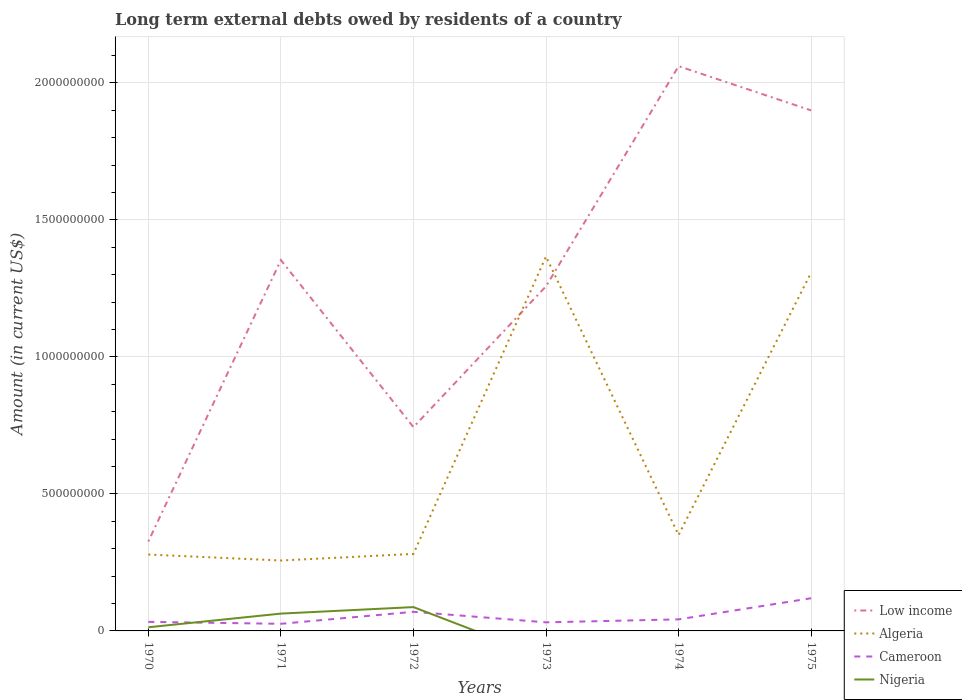How many different coloured lines are there?
Your answer should be compact. 4. Is the number of lines equal to the number of legend labels?
Keep it short and to the point. No. Across all years, what is the maximum amount of long-term external debts owed by residents in Cameroon?
Keep it short and to the point. 2.60e+07. What is the total amount of long-term external debts owed by residents in Low income in the graph?
Provide a succinct answer. -6.42e+08. What is the difference between the highest and the second highest amount of long-term external debts owed by residents in Nigeria?
Offer a very short reply. 8.69e+07. What is the difference between the highest and the lowest amount of long-term external debts owed by residents in Algeria?
Offer a terse response. 2. Is the amount of long-term external debts owed by residents in Low income strictly greater than the amount of long-term external debts owed by residents in Cameroon over the years?
Keep it short and to the point. No. How many years are there in the graph?
Ensure brevity in your answer.  6. What is the difference between two consecutive major ticks on the Y-axis?
Provide a succinct answer. 5.00e+08. Where does the legend appear in the graph?
Your answer should be very brief. Bottom right. How many legend labels are there?
Offer a very short reply. 4. What is the title of the graph?
Keep it short and to the point. Long term external debts owed by residents of a country. What is the label or title of the Y-axis?
Ensure brevity in your answer.  Amount (in current US$). What is the Amount (in current US$) in Low income in 1970?
Ensure brevity in your answer.  3.26e+08. What is the Amount (in current US$) of Algeria in 1970?
Give a very brief answer. 2.79e+08. What is the Amount (in current US$) in Cameroon in 1970?
Make the answer very short. 3.30e+07. What is the Amount (in current US$) of Nigeria in 1970?
Provide a short and direct response. 1.33e+07. What is the Amount (in current US$) in Low income in 1971?
Your answer should be very brief. 1.35e+09. What is the Amount (in current US$) in Algeria in 1971?
Your answer should be compact. 2.57e+08. What is the Amount (in current US$) in Cameroon in 1971?
Your answer should be compact. 2.60e+07. What is the Amount (in current US$) in Nigeria in 1971?
Your answer should be very brief. 6.32e+07. What is the Amount (in current US$) in Low income in 1972?
Make the answer very short. 7.44e+08. What is the Amount (in current US$) of Algeria in 1972?
Keep it short and to the point. 2.81e+08. What is the Amount (in current US$) of Cameroon in 1972?
Give a very brief answer. 6.98e+07. What is the Amount (in current US$) of Nigeria in 1972?
Your response must be concise. 8.69e+07. What is the Amount (in current US$) of Low income in 1973?
Ensure brevity in your answer.  1.26e+09. What is the Amount (in current US$) of Algeria in 1973?
Give a very brief answer. 1.37e+09. What is the Amount (in current US$) in Cameroon in 1973?
Your answer should be compact. 3.13e+07. What is the Amount (in current US$) in Nigeria in 1973?
Offer a very short reply. 0. What is the Amount (in current US$) in Low income in 1974?
Keep it short and to the point. 2.06e+09. What is the Amount (in current US$) in Algeria in 1974?
Offer a terse response. 3.50e+08. What is the Amount (in current US$) of Cameroon in 1974?
Your response must be concise. 4.22e+07. What is the Amount (in current US$) in Nigeria in 1974?
Provide a succinct answer. 0. What is the Amount (in current US$) of Low income in 1975?
Provide a short and direct response. 1.90e+09. What is the Amount (in current US$) of Algeria in 1975?
Your response must be concise. 1.31e+09. What is the Amount (in current US$) of Cameroon in 1975?
Provide a short and direct response. 1.19e+08. Across all years, what is the maximum Amount (in current US$) of Low income?
Your answer should be very brief. 2.06e+09. Across all years, what is the maximum Amount (in current US$) of Algeria?
Provide a short and direct response. 1.37e+09. Across all years, what is the maximum Amount (in current US$) in Cameroon?
Keep it short and to the point. 1.19e+08. Across all years, what is the maximum Amount (in current US$) of Nigeria?
Keep it short and to the point. 8.69e+07. Across all years, what is the minimum Amount (in current US$) in Low income?
Your response must be concise. 3.26e+08. Across all years, what is the minimum Amount (in current US$) in Algeria?
Offer a terse response. 2.57e+08. Across all years, what is the minimum Amount (in current US$) in Cameroon?
Offer a terse response. 2.60e+07. Across all years, what is the minimum Amount (in current US$) of Nigeria?
Keep it short and to the point. 0. What is the total Amount (in current US$) of Low income in the graph?
Provide a succinct answer. 7.64e+09. What is the total Amount (in current US$) in Algeria in the graph?
Provide a succinct answer. 3.84e+09. What is the total Amount (in current US$) in Cameroon in the graph?
Provide a succinct answer. 3.22e+08. What is the total Amount (in current US$) of Nigeria in the graph?
Your answer should be very brief. 1.63e+08. What is the difference between the Amount (in current US$) of Low income in 1970 and that in 1971?
Provide a short and direct response. -1.03e+09. What is the difference between the Amount (in current US$) in Algeria in 1970 and that in 1971?
Your response must be concise. 2.18e+07. What is the difference between the Amount (in current US$) of Cameroon in 1970 and that in 1971?
Provide a short and direct response. 7.06e+06. What is the difference between the Amount (in current US$) of Nigeria in 1970 and that in 1971?
Your answer should be compact. -4.99e+07. What is the difference between the Amount (in current US$) of Low income in 1970 and that in 1972?
Keep it short and to the point. -4.17e+08. What is the difference between the Amount (in current US$) of Algeria in 1970 and that in 1972?
Keep it short and to the point. -2.27e+06. What is the difference between the Amount (in current US$) of Cameroon in 1970 and that in 1972?
Keep it short and to the point. -3.68e+07. What is the difference between the Amount (in current US$) of Nigeria in 1970 and that in 1972?
Offer a terse response. -7.36e+07. What is the difference between the Amount (in current US$) of Low income in 1970 and that in 1973?
Offer a very short reply. -9.31e+08. What is the difference between the Amount (in current US$) of Algeria in 1970 and that in 1973?
Your answer should be very brief. -1.09e+09. What is the difference between the Amount (in current US$) of Cameroon in 1970 and that in 1973?
Offer a terse response. 1.72e+06. What is the difference between the Amount (in current US$) of Low income in 1970 and that in 1974?
Your response must be concise. -1.73e+09. What is the difference between the Amount (in current US$) in Algeria in 1970 and that in 1974?
Keep it short and to the point. -7.12e+07. What is the difference between the Amount (in current US$) of Cameroon in 1970 and that in 1974?
Your answer should be very brief. -9.16e+06. What is the difference between the Amount (in current US$) in Low income in 1970 and that in 1975?
Keep it short and to the point. -1.57e+09. What is the difference between the Amount (in current US$) in Algeria in 1970 and that in 1975?
Keep it short and to the point. -1.03e+09. What is the difference between the Amount (in current US$) in Cameroon in 1970 and that in 1975?
Your answer should be compact. -8.63e+07. What is the difference between the Amount (in current US$) in Low income in 1971 and that in 1972?
Your answer should be compact. 6.10e+08. What is the difference between the Amount (in current US$) of Algeria in 1971 and that in 1972?
Your answer should be very brief. -2.41e+07. What is the difference between the Amount (in current US$) of Cameroon in 1971 and that in 1972?
Make the answer very short. -4.38e+07. What is the difference between the Amount (in current US$) of Nigeria in 1971 and that in 1972?
Your response must be concise. -2.37e+07. What is the difference between the Amount (in current US$) in Low income in 1971 and that in 1973?
Ensure brevity in your answer.  9.57e+07. What is the difference between the Amount (in current US$) of Algeria in 1971 and that in 1973?
Your answer should be compact. -1.11e+09. What is the difference between the Amount (in current US$) of Cameroon in 1971 and that in 1973?
Offer a very short reply. -5.34e+06. What is the difference between the Amount (in current US$) in Low income in 1971 and that in 1974?
Offer a very short reply. -7.08e+08. What is the difference between the Amount (in current US$) in Algeria in 1971 and that in 1974?
Ensure brevity in your answer.  -9.29e+07. What is the difference between the Amount (in current US$) of Cameroon in 1971 and that in 1974?
Provide a short and direct response. -1.62e+07. What is the difference between the Amount (in current US$) of Low income in 1971 and that in 1975?
Provide a short and direct response. -5.46e+08. What is the difference between the Amount (in current US$) of Algeria in 1971 and that in 1975?
Your response must be concise. -1.05e+09. What is the difference between the Amount (in current US$) in Cameroon in 1971 and that in 1975?
Make the answer very short. -9.33e+07. What is the difference between the Amount (in current US$) of Low income in 1972 and that in 1973?
Keep it short and to the point. -5.14e+08. What is the difference between the Amount (in current US$) of Algeria in 1972 and that in 1973?
Keep it short and to the point. -1.09e+09. What is the difference between the Amount (in current US$) of Cameroon in 1972 and that in 1973?
Offer a very short reply. 3.85e+07. What is the difference between the Amount (in current US$) of Low income in 1972 and that in 1974?
Give a very brief answer. -1.32e+09. What is the difference between the Amount (in current US$) of Algeria in 1972 and that in 1974?
Provide a succinct answer. -6.89e+07. What is the difference between the Amount (in current US$) in Cameroon in 1972 and that in 1974?
Your answer should be very brief. 2.76e+07. What is the difference between the Amount (in current US$) in Low income in 1972 and that in 1975?
Give a very brief answer. -1.16e+09. What is the difference between the Amount (in current US$) of Algeria in 1972 and that in 1975?
Ensure brevity in your answer.  -1.03e+09. What is the difference between the Amount (in current US$) in Cameroon in 1972 and that in 1975?
Ensure brevity in your answer.  -4.95e+07. What is the difference between the Amount (in current US$) of Low income in 1973 and that in 1974?
Make the answer very short. -8.03e+08. What is the difference between the Amount (in current US$) of Algeria in 1973 and that in 1974?
Your answer should be very brief. 1.02e+09. What is the difference between the Amount (in current US$) in Cameroon in 1973 and that in 1974?
Make the answer very short. -1.09e+07. What is the difference between the Amount (in current US$) in Low income in 1973 and that in 1975?
Offer a very short reply. -6.42e+08. What is the difference between the Amount (in current US$) of Algeria in 1973 and that in 1975?
Make the answer very short. 5.86e+07. What is the difference between the Amount (in current US$) in Cameroon in 1973 and that in 1975?
Offer a very short reply. -8.80e+07. What is the difference between the Amount (in current US$) of Low income in 1974 and that in 1975?
Your answer should be very brief. 1.61e+08. What is the difference between the Amount (in current US$) in Algeria in 1974 and that in 1975?
Your answer should be very brief. -9.58e+08. What is the difference between the Amount (in current US$) of Cameroon in 1974 and that in 1975?
Your response must be concise. -7.71e+07. What is the difference between the Amount (in current US$) in Low income in 1970 and the Amount (in current US$) in Algeria in 1971?
Keep it short and to the point. 6.93e+07. What is the difference between the Amount (in current US$) in Low income in 1970 and the Amount (in current US$) in Cameroon in 1971?
Give a very brief answer. 3.00e+08. What is the difference between the Amount (in current US$) in Low income in 1970 and the Amount (in current US$) in Nigeria in 1971?
Make the answer very short. 2.63e+08. What is the difference between the Amount (in current US$) in Algeria in 1970 and the Amount (in current US$) in Cameroon in 1971?
Your response must be concise. 2.53e+08. What is the difference between the Amount (in current US$) of Algeria in 1970 and the Amount (in current US$) of Nigeria in 1971?
Your response must be concise. 2.16e+08. What is the difference between the Amount (in current US$) of Cameroon in 1970 and the Amount (in current US$) of Nigeria in 1971?
Keep it short and to the point. -3.02e+07. What is the difference between the Amount (in current US$) in Low income in 1970 and the Amount (in current US$) in Algeria in 1972?
Keep it short and to the point. 4.52e+07. What is the difference between the Amount (in current US$) of Low income in 1970 and the Amount (in current US$) of Cameroon in 1972?
Offer a very short reply. 2.56e+08. What is the difference between the Amount (in current US$) in Low income in 1970 and the Amount (in current US$) in Nigeria in 1972?
Provide a short and direct response. 2.39e+08. What is the difference between the Amount (in current US$) in Algeria in 1970 and the Amount (in current US$) in Cameroon in 1972?
Make the answer very short. 2.09e+08. What is the difference between the Amount (in current US$) of Algeria in 1970 and the Amount (in current US$) of Nigeria in 1972?
Your response must be concise. 1.92e+08. What is the difference between the Amount (in current US$) in Cameroon in 1970 and the Amount (in current US$) in Nigeria in 1972?
Make the answer very short. -5.39e+07. What is the difference between the Amount (in current US$) in Low income in 1970 and the Amount (in current US$) in Algeria in 1973?
Offer a very short reply. -1.04e+09. What is the difference between the Amount (in current US$) of Low income in 1970 and the Amount (in current US$) of Cameroon in 1973?
Your response must be concise. 2.95e+08. What is the difference between the Amount (in current US$) in Algeria in 1970 and the Amount (in current US$) in Cameroon in 1973?
Give a very brief answer. 2.47e+08. What is the difference between the Amount (in current US$) of Low income in 1970 and the Amount (in current US$) of Algeria in 1974?
Your answer should be compact. -2.36e+07. What is the difference between the Amount (in current US$) of Low income in 1970 and the Amount (in current US$) of Cameroon in 1974?
Keep it short and to the point. 2.84e+08. What is the difference between the Amount (in current US$) of Algeria in 1970 and the Amount (in current US$) of Cameroon in 1974?
Provide a succinct answer. 2.37e+08. What is the difference between the Amount (in current US$) in Low income in 1970 and the Amount (in current US$) in Algeria in 1975?
Provide a short and direct response. -9.81e+08. What is the difference between the Amount (in current US$) in Low income in 1970 and the Amount (in current US$) in Cameroon in 1975?
Offer a terse response. 2.07e+08. What is the difference between the Amount (in current US$) of Algeria in 1970 and the Amount (in current US$) of Cameroon in 1975?
Keep it short and to the point. 1.59e+08. What is the difference between the Amount (in current US$) of Low income in 1971 and the Amount (in current US$) of Algeria in 1972?
Your answer should be compact. 1.07e+09. What is the difference between the Amount (in current US$) in Low income in 1971 and the Amount (in current US$) in Cameroon in 1972?
Provide a short and direct response. 1.28e+09. What is the difference between the Amount (in current US$) of Low income in 1971 and the Amount (in current US$) of Nigeria in 1972?
Offer a very short reply. 1.27e+09. What is the difference between the Amount (in current US$) of Algeria in 1971 and the Amount (in current US$) of Cameroon in 1972?
Give a very brief answer. 1.87e+08. What is the difference between the Amount (in current US$) in Algeria in 1971 and the Amount (in current US$) in Nigeria in 1972?
Your answer should be compact. 1.70e+08. What is the difference between the Amount (in current US$) in Cameroon in 1971 and the Amount (in current US$) in Nigeria in 1972?
Provide a succinct answer. -6.10e+07. What is the difference between the Amount (in current US$) of Low income in 1971 and the Amount (in current US$) of Algeria in 1973?
Ensure brevity in your answer.  -1.29e+07. What is the difference between the Amount (in current US$) in Low income in 1971 and the Amount (in current US$) in Cameroon in 1973?
Ensure brevity in your answer.  1.32e+09. What is the difference between the Amount (in current US$) in Algeria in 1971 and the Amount (in current US$) in Cameroon in 1973?
Make the answer very short. 2.26e+08. What is the difference between the Amount (in current US$) of Low income in 1971 and the Amount (in current US$) of Algeria in 1974?
Offer a terse response. 1.00e+09. What is the difference between the Amount (in current US$) of Low income in 1971 and the Amount (in current US$) of Cameroon in 1974?
Your answer should be compact. 1.31e+09. What is the difference between the Amount (in current US$) of Algeria in 1971 and the Amount (in current US$) of Cameroon in 1974?
Your response must be concise. 2.15e+08. What is the difference between the Amount (in current US$) in Low income in 1971 and the Amount (in current US$) in Algeria in 1975?
Provide a succinct answer. 4.57e+07. What is the difference between the Amount (in current US$) of Low income in 1971 and the Amount (in current US$) of Cameroon in 1975?
Make the answer very short. 1.23e+09. What is the difference between the Amount (in current US$) in Algeria in 1971 and the Amount (in current US$) in Cameroon in 1975?
Ensure brevity in your answer.  1.38e+08. What is the difference between the Amount (in current US$) in Low income in 1972 and the Amount (in current US$) in Algeria in 1973?
Keep it short and to the point. -6.23e+08. What is the difference between the Amount (in current US$) in Low income in 1972 and the Amount (in current US$) in Cameroon in 1973?
Your response must be concise. 7.12e+08. What is the difference between the Amount (in current US$) of Algeria in 1972 and the Amount (in current US$) of Cameroon in 1973?
Give a very brief answer. 2.50e+08. What is the difference between the Amount (in current US$) of Low income in 1972 and the Amount (in current US$) of Algeria in 1974?
Provide a short and direct response. 3.94e+08. What is the difference between the Amount (in current US$) in Low income in 1972 and the Amount (in current US$) in Cameroon in 1974?
Your response must be concise. 7.02e+08. What is the difference between the Amount (in current US$) in Algeria in 1972 and the Amount (in current US$) in Cameroon in 1974?
Give a very brief answer. 2.39e+08. What is the difference between the Amount (in current US$) of Low income in 1972 and the Amount (in current US$) of Algeria in 1975?
Give a very brief answer. -5.64e+08. What is the difference between the Amount (in current US$) of Low income in 1972 and the Amount (in current US$) of Cameroon in 1975?
Make the answer very short. 6.24e+08. What is the difference between the Amount (in current US$) in Algeria in 1972 and the Amount (in current US$) in Cameroon in 1975?
Keep it short and to the point. 1.62e+08. What is the difference between the Amount (in current US$) in Low income in 1973 and the Amount (in current US$) in Algeria in 1974?
Your answer should be compact. 9.08e+08. What is the difference between the Amount (in current US$) in Low income in 1973 and the Amount (in current US$) in Cameroon in 1974?
Your answer should be very brief. 1.22e+09. What is the difference between the Amount (in current US$) of Algeria in 1973 and the Amount (in current US$) of Cameroon in 1974?
Offer a terse response. 1.32e+09. What is the difference between the Amount (in current US$) of Low income in 1973 and the Amount (in current US$) of Algeria in 1975?
Your answer should be compact. -5.00e+07. What is the difference between the Amount (in current US$) of Low income in 1973 and the Amount (in current US$) of Cameroon in 1975?
Your response must be concise. 1.14e+09. What is the difference between the Amount (in current US$) in Algeria in 1973 and the Amount (in current US$) in Cameroon in 1975?
Your response must be concise. 1.25e+09. What is the difference between the Amount (in current US$) in Low income in 1974 and the Amount (in current US$) in Algeria in 1975?
Offer a terse response. 7.53e+08. What is the difference between the Amount (in current US$) in Low income in 1974 and the Amount (in current US$) in Cameroon in 1975?
Ensure brevity in your answer.  1.94e+09. What is the difference between the Amount (in current US$) of Algeria in 1974 and the Amount (in current US$) of Cameroon in 1975?
Your response must be concise. 2.31e+08. What is the average Amount (in current US$) of Low income per year?
Your answer should be compact. 1.27e+09. What is the average Amount (in current US$) in Algeria per year?
Keep it short and to the point. 6.40e+08. What is the average Amount (in current US$) of Cameroon per year?
Make the answer very short. 5.36e+07. What is the average Amount (in current US$) in Nigeria per year?
Your response must be concise. 2.72e+07. In the year 1970, what is the difference between the Amount (in current US$) in Low income and Amount (in current US$) in Algeria?
Give a very brief answer. 4.75e+07. In the year 1970, what is the difference between the Amount (in current US$) in Low income and Amount (in current US$) in Cameroon?
Keep it short and to the point. 2.93e+08. In the year 1970, what is the difference between the Amount (in current US$) in Low income and Amount (in current US$) in Nigeria?
Your answer should be compact. 3.13e+08. In the year 1970, what is the difference between the Amount (in current US$) of Algeria and Amount (in current US$) of Cameroon?
Make the answer very short. 2.46e+08. In the year 1970, what is the difference between the Amount (in current US$) in Algeria and Amount (in current US$) in Nigeria?
Keep it short and to the point. 2.65e+08. In the year 1970, what is the difference between the Amount (in current US$) of Cameroon and Amount (in current US$) of Nigeria?
Make the answer very short. 1.97e+07. In the year 1971, what is the difference between the Amount (in current US$) of Low income and Amount (in current US$) of Algeria?
Your answer should be very brief. 1.10e+09. In the year 1971, what is the difference between the Amount (in current US$) of Low income and Amount (in current US$) of Cameroon?
Give a very brief answer. 1.33e+09. In the year 1971, what is the difference between the Amount (in current US$) of Low income and Amount (in current US$) of Nigeria?
Keep it short and to the point. 1.29e+09. In the year 1971, what is the difference between the Amount (in current US$) in Algeria and Amount (in current US$) in Cameroon?
Ensure brevity in your answer.  2.31e+08. In the year 1971, what is the difference between the Amount (in current US$) in Algeria and Amount (in current US$) in Nigeria?
Provide a succinct answer. 1.94e+08. In the year 1971, what is the difference between the Amount (in current US$) of Cameroon and Amount (in current US$) of Nigeria?
Make the answer very short. -3.72e+07. In the year 1972, what is the difference between the Amount (in current US$) in Low income and Amount (in current US$) in Algeria?
Your answer should be compact. 4.63e+08. In the year 1972, what is the difference between the Amount (in current US$) of Low income and Amount (in current US$) of Cameroon?
Your response must be concise. 6.74e+08. In the year 1972, what is the difference between the Amount (in current US$) of Low income and Amount (in current US$) of Nigeria?
Offer a very short reply. 6.57e+08. In the year 1972, what is the difference between the Amount (in current US$) in Algeria and Amount (in current US$) in Cameroon?
Ensure brevity in your answer.  2.11e+08. In the year 1972, what is the difference between the Amount (in current US$) of Algeria and Amount (in current US$) of Nigeria?
Keep it short and to the point. 1.94e+08. In the year 1972, what is the difference between the Amount (in current US$) of Cameroon and Amount (in current US$) of Nigeria?
Make the answer very short. -1.71e+07. In the year 1973, what is the difference between the Amount (in current US$) of Low income and Amount (in current US$) of Algeria?
Offer a terse response. -1.09e+08. In the year 1973, what is the difference between the Amount (in current US$) in Low income and Amount (in current US$) in Cameroon?
Give a very brief answer. 1.23e+09. In the year 1973, what is the difference between the Amount (in current US$) of Algeria and Amount (in current US$) of Cameroon?
Offer a very short reply. 1.34e+09. In the year 1974, what is the difference between the Amount (in current US$) in Low income and Amount (in current US$) in Algeria?
Keep it short and to the point. 1.71e+09. In the year 1974, what is the difference between the Amount (in current US$) of Low income and Amount (in current US$) of Cameroon?
Your answer should be compact. 2.02e+09. In the year 1974, what is the difference between the Amount (in current US$) in Algeria and Amount (in current US$) in Cameroon?
Give a very brief answer. 3.08e+08. In the year 1975, what is the difference between the Amount (in current US$) in Low income and Amount (in current US$) in Algeria?
Offer a very short reply. 5.92e+08. In the year 1975, what is the difference between the Amount (in current US$) of Low income and Amount (in current US$) of Cameroon?
Give a very brief answer. 1.78e+09. In the year 1975, what is the difference between the Amount (in current US$) of Algeria and Amount (in current US$) of Cameroon?
Your answer should be very brief. 1.19e+09. What is the ratio of the Amount (in current US$) in Low income in 1970 to that in 1971?
Ensure brevity in your answer.  0.24. What is the ratio of the Amount (in current US$) of Algeria in 1970 to that in 1971?
Offer a terse response. 1.08. What is the ratio of the Amount (in current US$) in Cameroon in 1970 to that in 1971?
Your answer should be compact. 1.27. What is the ratio of the Amount (in current US$) in Nigeria in 1970 to that in 1971?
Your response must be concise. 0.21. What is the ratio of the Amount (in current US$) of Low income in 1970 to that in 1972?
Your answer should be very brief. 0.44. What is the ratio of the Amount (in current US$) in Cameroon in 1970 to that in 1972?
Your answer should be compact. 0.47. What is the ratio of the Amount (in current US$) of Nigeria in 1970 to that in 1972?
Ensure brevity in your answer.  0.15. What is the ratio of the Amount (in current US$) of Low income in 1970 to that in 1973?
Provide a short and direct response. 0.26. What is the ratio of the Amount (in current US$) of Algeria in 1970 to that in 1973?
Your answer should be compact. 0.2. What is the ratio of the Amount (in current US$) of Cameroon in 1970 to that in 1973?
Give a very brief answer. 1.05. What is the ratio of the Amount (in current US$) in Low income in 1970 to that in 1974?
Offer a very short reply. 0.16. What is the ratio of the Amount (in current US$) in Algeria in 1970 to that in 1974?
Your response must be concise. 0.8. What is the ratio of the Amount (in current US$) of Cameroon in 1970 to that in 1974?
Provide a short and direct response. 0.78. What is the ratio of the Amount (in current US$) of Low income in 1970 to that in 1975?
Give a very brief answer. 0.17. What is the ratio of the Amount (in current US$) of Algeria in 1970 to that in 1975?
Make the answer very short. 0.21. What is the ratio of the Amount (in current US$) in Cameroon in 1970 to that in 1975?
Provide a short and direct response. 0.28. What is the ratio of the Amount (in current US$) of Low income in 1971 to that in 1972?
Keep it short and to the point. 1.82. What is the ratio of the Amount (in current US$) of Algeria in 1971 to that in 1972?
Your response must be concise. 0.91. What is the ratio of the Amount (in current US$) in Cameroon in 1971 to that in 1972?
Make the answer very short. 0.37. What is the ratio of the Amount (in current US$) in Nigeria in 1971 to that in 1972?
Offer a terse response. 0.73. What is the ratio of the Amount (in current US$) in Low income in 1971 to that in 1973?
Make the answer very short. 1.08. What is the ratio of the Amount (in current US$) in Algeria in 1971 to that in 1973?
Your answer should be compact. 0.19. What is the ratio of the Amount (in current US$) of Cameroon in 1971 to that in 1973?
Your answer should be very brief. 0.83. What is the ratio of the Amount (in current US$) of Low income in 1971 to that in 1974?
Make the answer very short. 0.66. What is the ratio of the Amount (in current US$) of Algeria in 1971 to that in 1974?
Provide a succinct answer. 0.73. What is the ratio of the Amount (in current US$) of Cameroon in 1971 to that in 1974?
Provide a short and direct response. 0.62. What is the ratio of the Amount (in current US$) of Low income in 1971 to that in 1975?
Offer a very short reply. 0.71. What is the ratio of the Amount (in current US$) of Algeria in 1971 to that in 1975?
Make the answer very short. 0.2. What is the ratio of the Amount (in current US$) of Cameroon in 1971 to that in 1975?
Offer a very short reply. 0.22. What is the ratio of the Amount (in current US$) of Low income in 1972 to that in 1973?
Give a very brief answer. 0.59. What is the ratio of the Amount (in current US$) in Algeria in 1972 to that in 1973?
Make the answer very short. 0.21. What is the ratio of the Amount (in current US$) of Cameroon in 1972 to that in 1973?
Provide a succinct answer. 2.23. What is the ratio of the Amount (in current US$) in Low income in 1972 to that in 1974?
Make the answer very short. 0.36. What is the ratio of the Amount (in current US$) of Algeria in 1972 to that in 1974?
Keep it short and to the point. 0.8. What is the ratio of the Amount (in current US$) in Cameroon in 1972 to that in 1974?
Provide a short and direct response. 1.65. What is the ratio of the Amount (in current US$) in Low income in 1972 to that in 1975?
Offer a very short reply. 0.39. What is the ratio of the Amount (in current US$) in Algeria in 1972 to that in 1975?
Keep it short and to the point. 0.21. What is the ratio of the Amount (in current US$) in Cameroon in 1972 to that in 1975?
Provide a short and direct response. 0.59. What is the ratio of the Amount (in current US$) in Low income in 1973 to that in 1974?
Make the answer very short. 0.61. What is the ratio of the Amount (in current US$) of Algeria in 1973 to that in 1974?
Ensure brevity in your answer.  3.9. What is the ratio of the Amount (in current US$) of Cameroon in 1973 to that in 1974?
Your answer should be compact. 0.74. What is the ratio of the Amount (in current US$) in Low income in 1973 to that in 1975?
Offer a very short reply. 0.66. What is the ratio of the Amount (in current US$) of Algeria in 1973 to that in 1975?
Keep it short and to the point. 1.04. What is the ratio of the Amount (in current US$) in Cameroon in 1973 to that in 1975?
Your response must be concise. 0.26. What is the ratio of the Amount (in current US$) of Low income in 1974 to that in 1975?
Your answer should be very brief. 1.08. What is the ratio of the Amount (in current US$) in Algeria in 1974 to that in 1975?
Offer a terse response. 0.27. What is the ratio of the Amount (in current US$) of Cameroon in 1974 to that in 1975?
Make the answer very short. 0.35. What is the difference between the highest and the second highest Amount (in current US$) of Low income?
Give a very brief answer. 1.61e+08. What is the difference between the highest and the second highest Amount (in current US$) in Algeria?
Give a very brief answer. 5.86e+07. What is the difference between the highest and the second highest Amount (in current US$) in Cameroon?
Make the answer very short. 4.95e+07. What is the difference between the highest and the second highest Amount (in current US$) of Nigeria?
Offer a terse response. 2.37e+07. What is the difference between the highest and the lowest Amount (in current US$) in Low income?
Provide a short and direct response. 1.73e+09. What is the difference between the highest and the lowest Amount (in current US$) in Algeria?
Make the answer very short. 1.11e+09. What is the difference between the highest and the lowest Amount (in current US$) in Cameroon?
Your answer should be compact. 9.33e+07. What is the difference between the highest and the lowest Amount (in current US$) in Nigeria?
Keep it short and to the point. 8.69e+07. 